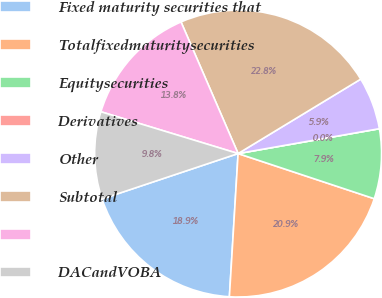Convert chart. <chart><loc_0><loc_0><loc_500><loc_500><pie_chart><fcel>Fixed maturity securities that<fcel>Totalfixedmaturitysecurities<fcel>Equitysecurities<fcel>Derivatives<fcel>Other<fcel>Subtotal<fcel>Unnamed: 6<fcel>DACandVOBA<nl><fcel>18.9%<fcel>20.87%<fcel>7.87%<fcel>0.0%<fcel>5.91%<fcel>22.83%<fcel>13.78%<fcel>9.84%<nl></chart> 